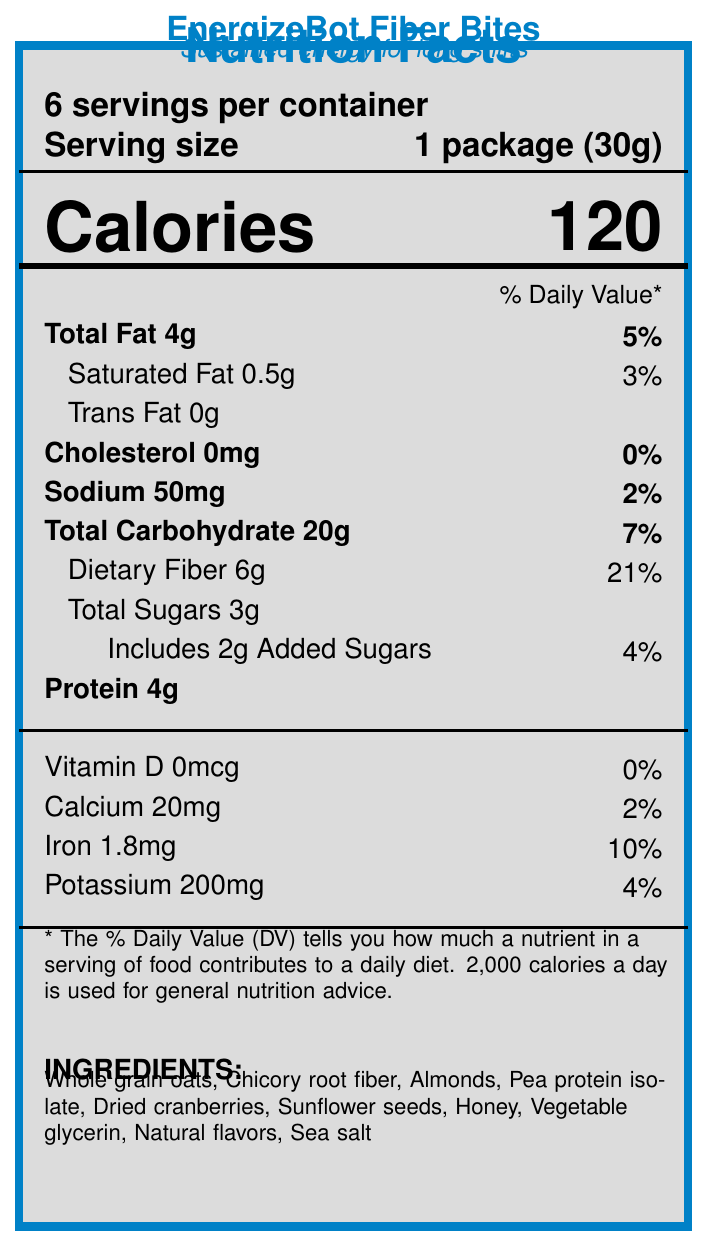what is the serving size? The serving size is listed clearly in the serving information section, indicating it is 1 package weighing 30 grams.
Answer: 1 package (30g) how many calories are in one serving? The calories per serving are prominently listed as 120 in the document.
Answer: 120 how much dietary fiber is in one serving? The document lists dietary fiber content as 6 grams under the nutrient table.
Answer: 6g what is the % daily value of iron per serving? The percentage daily value for iron is listed as 10% in the vitamin and mineral information section.
Answer: 10% what are the main ingredients? The document lists the ingredients clearly under the "INGREDIENTS" section.
Answer: Whole grain oats, Chicory root fiber, Almonds, Pea protein isolate, Dried cranberries, Sunflower seeds, Honey, Vegetable glycerin, Natural flavors, Sea salt how much protein is in one serving? The document shows that there is 4 grams of protein per serving in the nutrient table.
Answer: 4g what is the main selling point for this snack? A. Low in calories B. High fiber C. High sugar D. High sodium The document highlights "High in fiber" prominently in the marketing claims, making it the main selling point.
Answer: B what is the amount of calcium per serving? A. 10mg B. 20mg C. 50mg D. 100mg The nutrient table lists the amount of calcium per serving clearly as 20mg.
Answer: B is this product high in sodium? The document indicates that the sodium content is 50mg, which is just 2% of the daily value, classified as low sodium.
Answer: No describe the audience that this product targets The target audience is specified at the document's end section, focusing on manufacturing professionals.
Answer: Manufacturing professionals working with automated conveyor systems and robotics what are the benefits of consuming this snack during work? The marketing claims indicate these benefits clearly in the document.
Answer: Provides sustained energy, high in fiber, low sodium, good source of protein how many grams of added sugars are in one serving? The document shows that the snack includes 2 grams of added sugars per serving.
Answer: 2g is the product gluten-free? The document does not provide information on whether the product is gluten-free or not.
Answer: Cannot be determined what is the % daily value of total carbohydrates? The document lists the percent daily value for total carbohydrates as 7% in the nutrient table.
Answer: 7% 